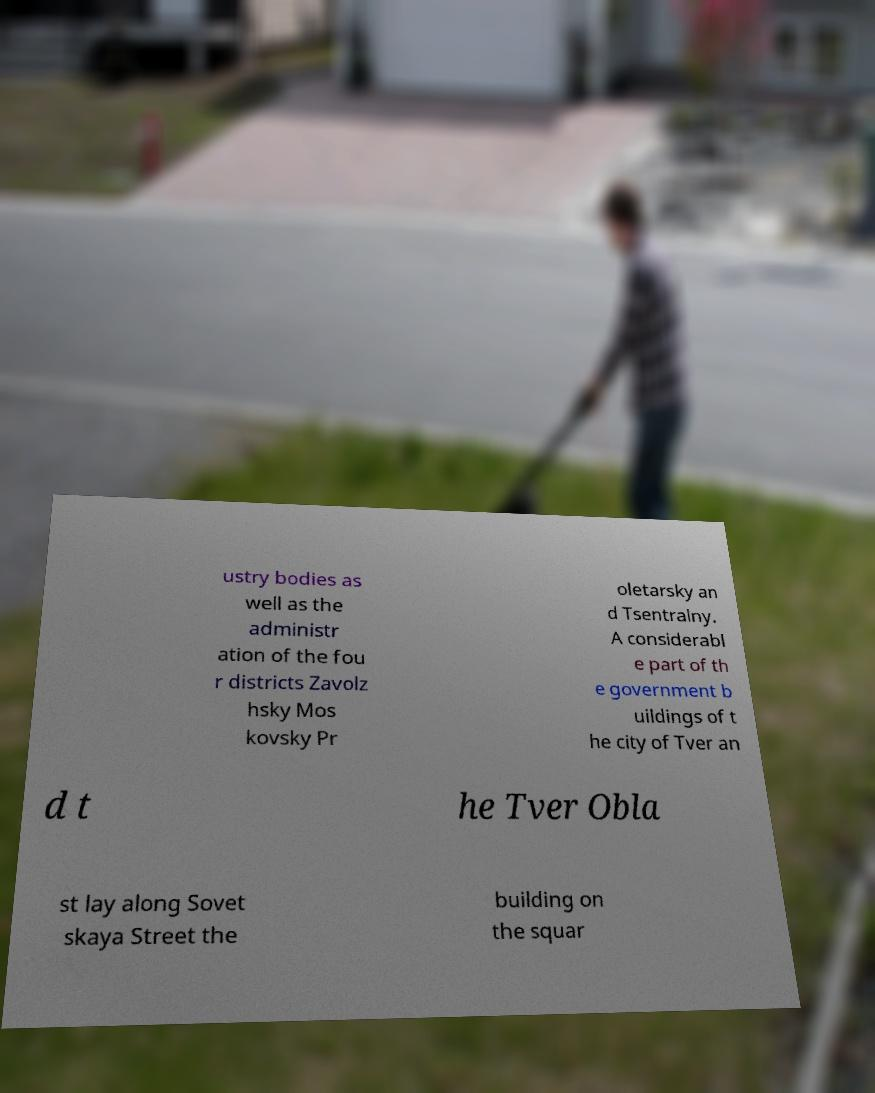For documentation purposes, I need the text within this image transcribed. Could you provide that? ustry bodies as well as the administr ation of the fou r districts Zavolz hsky Mos kovsky Pr oletarsky an d Tsentralny. A considerabl e part of th e government b uildings of t he city of Tver an d t he Tver Obla st lay along Sovet skaya Street the building on the squar 